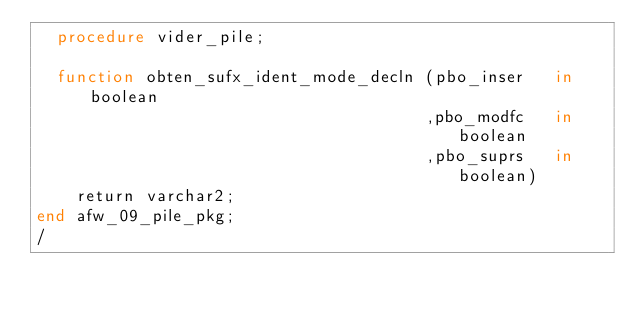Convert code to text. <code><loc_0><loc_0><loc_500><loc_500><_SQL_>  procedure vider_pile;

  function obten_sufx_ident_mode_decln (pbo_inser   in boolean
                                       ,pbo_modfc   in boolean
                                       ,pbo_suprs   in boolean)
    return varchar2;
end afw_09_pile_pkg;
/
</code> 